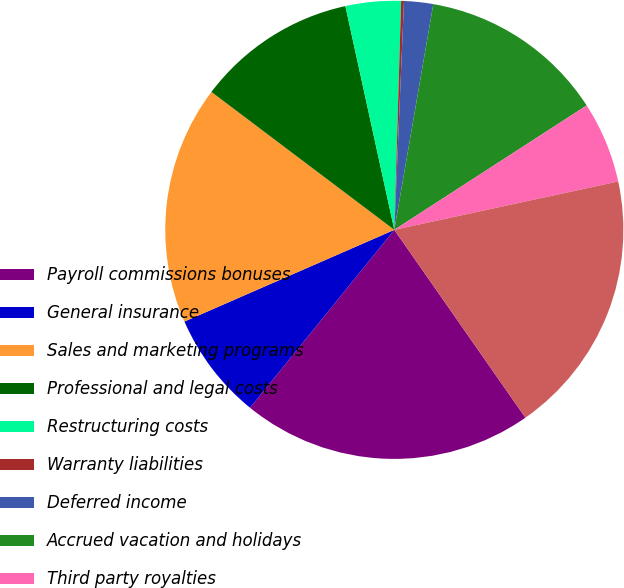Convert chart to OTSL. <chart><loc_0><loc_0><loc_500><loc_500><pie_chart><fcel>Payroll commissions bonuses<fcel>General insurance<fcel>Sales and marketing programs<fcel>Professional and legal costs<fcel>Restructuring costs<fcel>Warranty liabilities<fcel>Deferred income<fcel>Accrued vacation and holidays<fcel>Third party royalties<fcel>Current portion of derivatives<nl><fcel>20.54%<fcel>7.6%<fcel>16.84%<fcel>11.29%<fcel>3.9%<fcel>0.2%<fcel>2.05%<fcel>13.14%<fcel>5.75%<fcel>18.69%<nl></chart> 